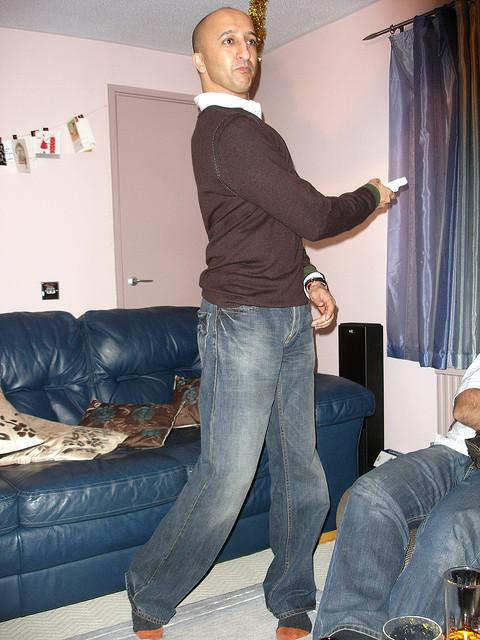What process is used to create the pillow fabric?

Choices:
A) embroidery
B) painting
C) knitting
D) quilting embroidery 